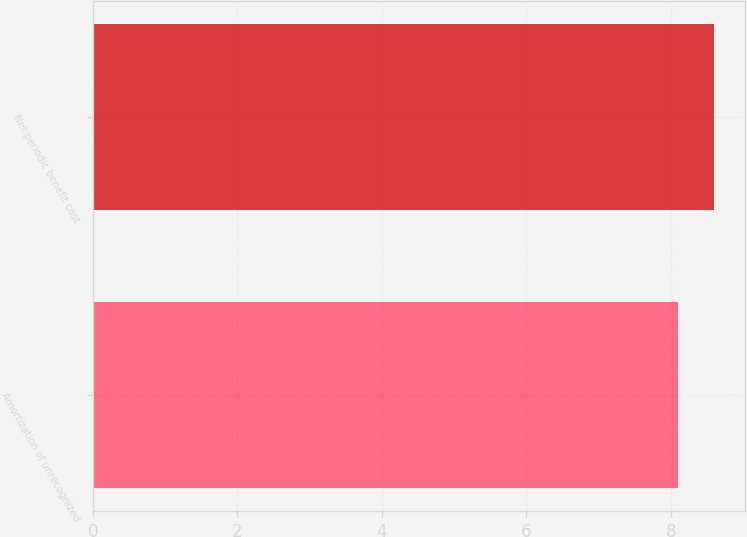Convert chart to OTSL. <chart><loc_0><loc_0><loc_500><loc_500><bar_chart><fcel>Amortization of unrecognized<fcel>Net periodic benefit cost<nl><fcel>8.1<fcel>8.6<nl></chart> 